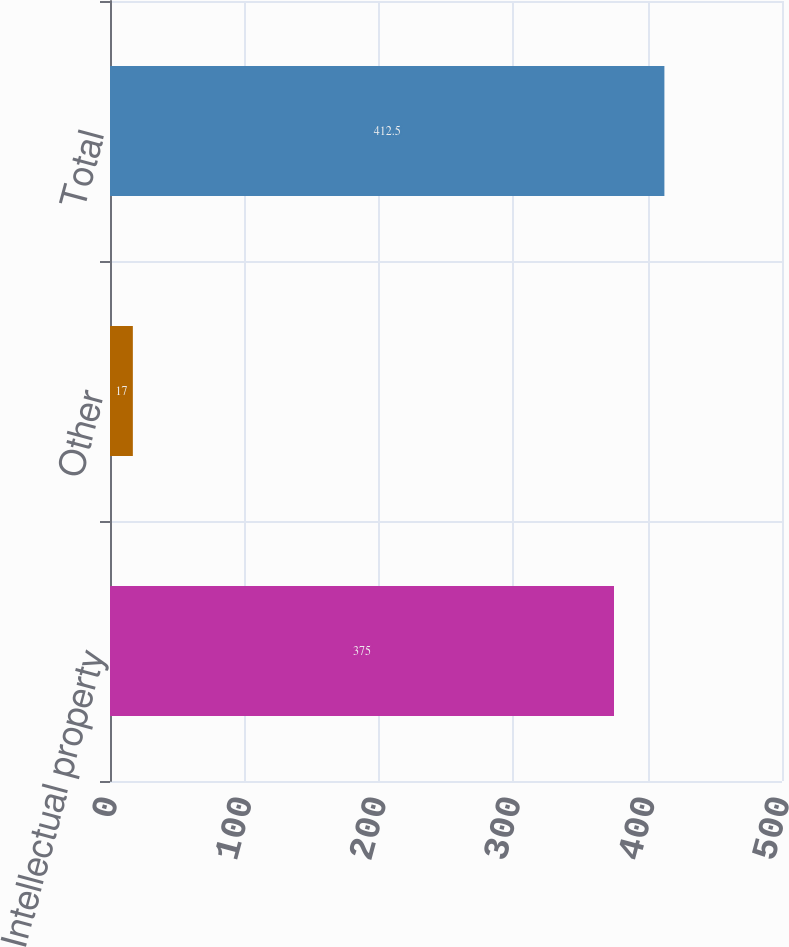<chart> <loc_0><loc_0><loc_500><loc_500><bar_chart><fcel>Intellectual property<fcel>Other<fcel>Total<nl><fcel>375<fcel>17<fcel>412.5<nl></chart> 